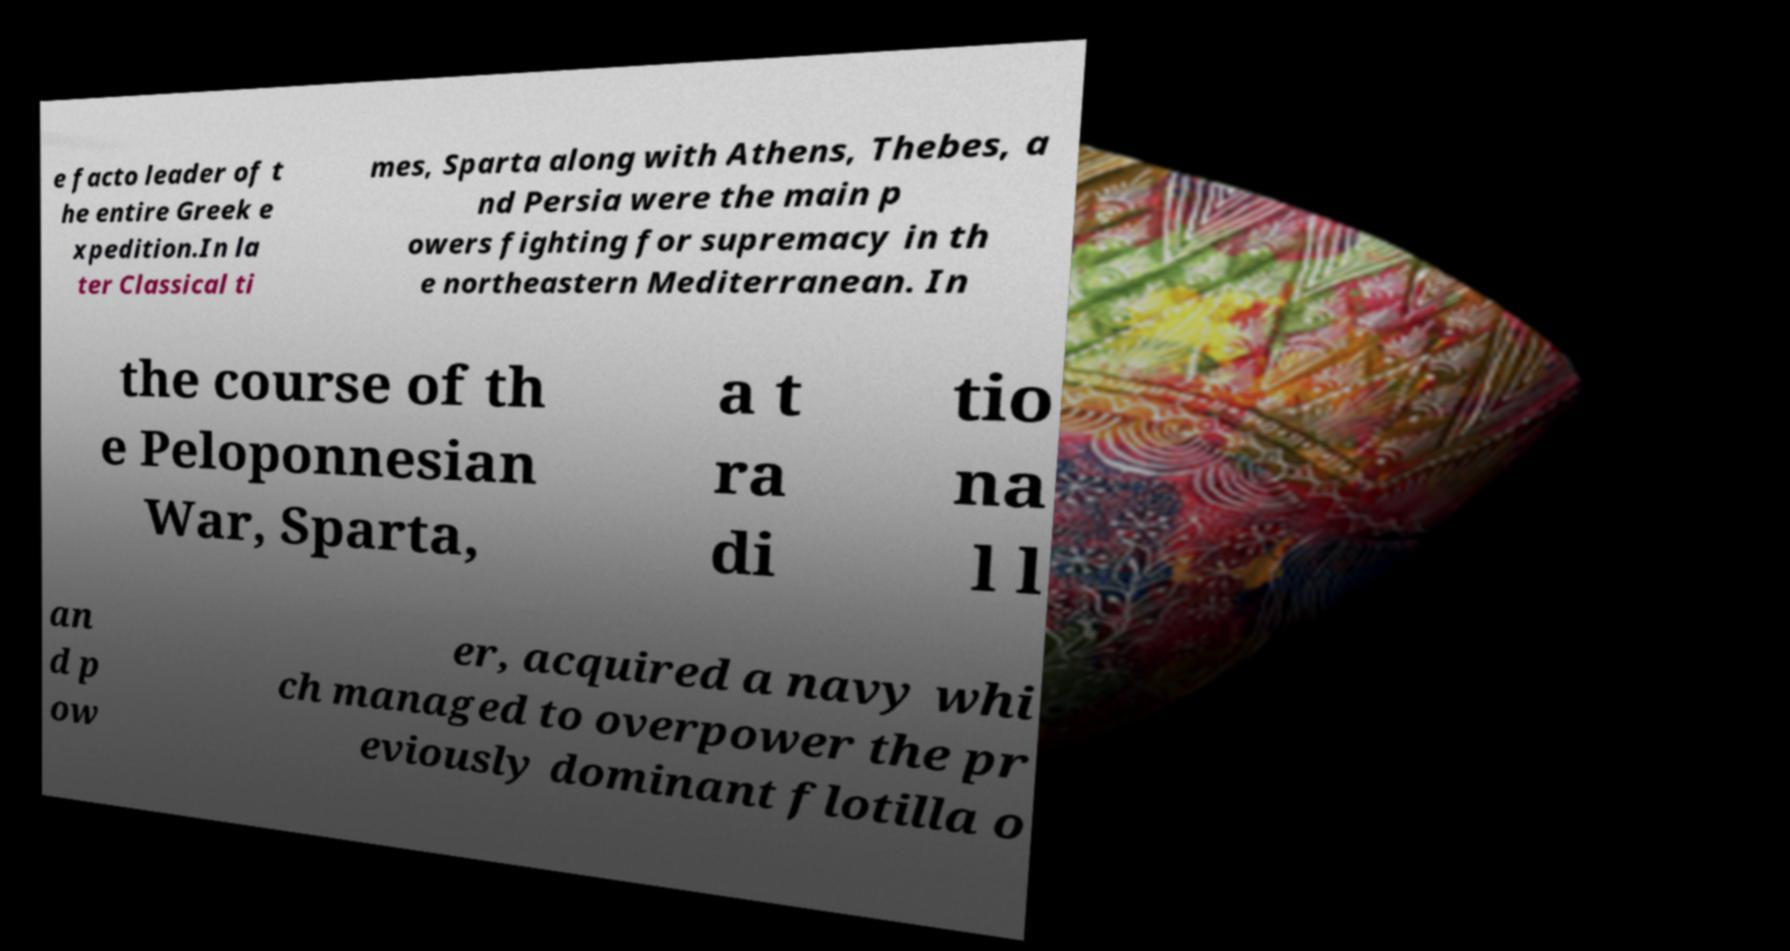Could you assist in decoding the text presented in this image and type it out clearly? e facto leader of t he entire Greek e xpedition.In la ter Classical ti mes, Sparta along with Athens, Thebes, a nd Persia were the main p owers fighting for supremacy in th e northeastern Mediterranean. In the course of th e Peloponnesian War, Sparta, a t ra di tio na l l an d p ow er, acquired a navy whi ch managed to overpower the pr eviously dominant flotilla o 